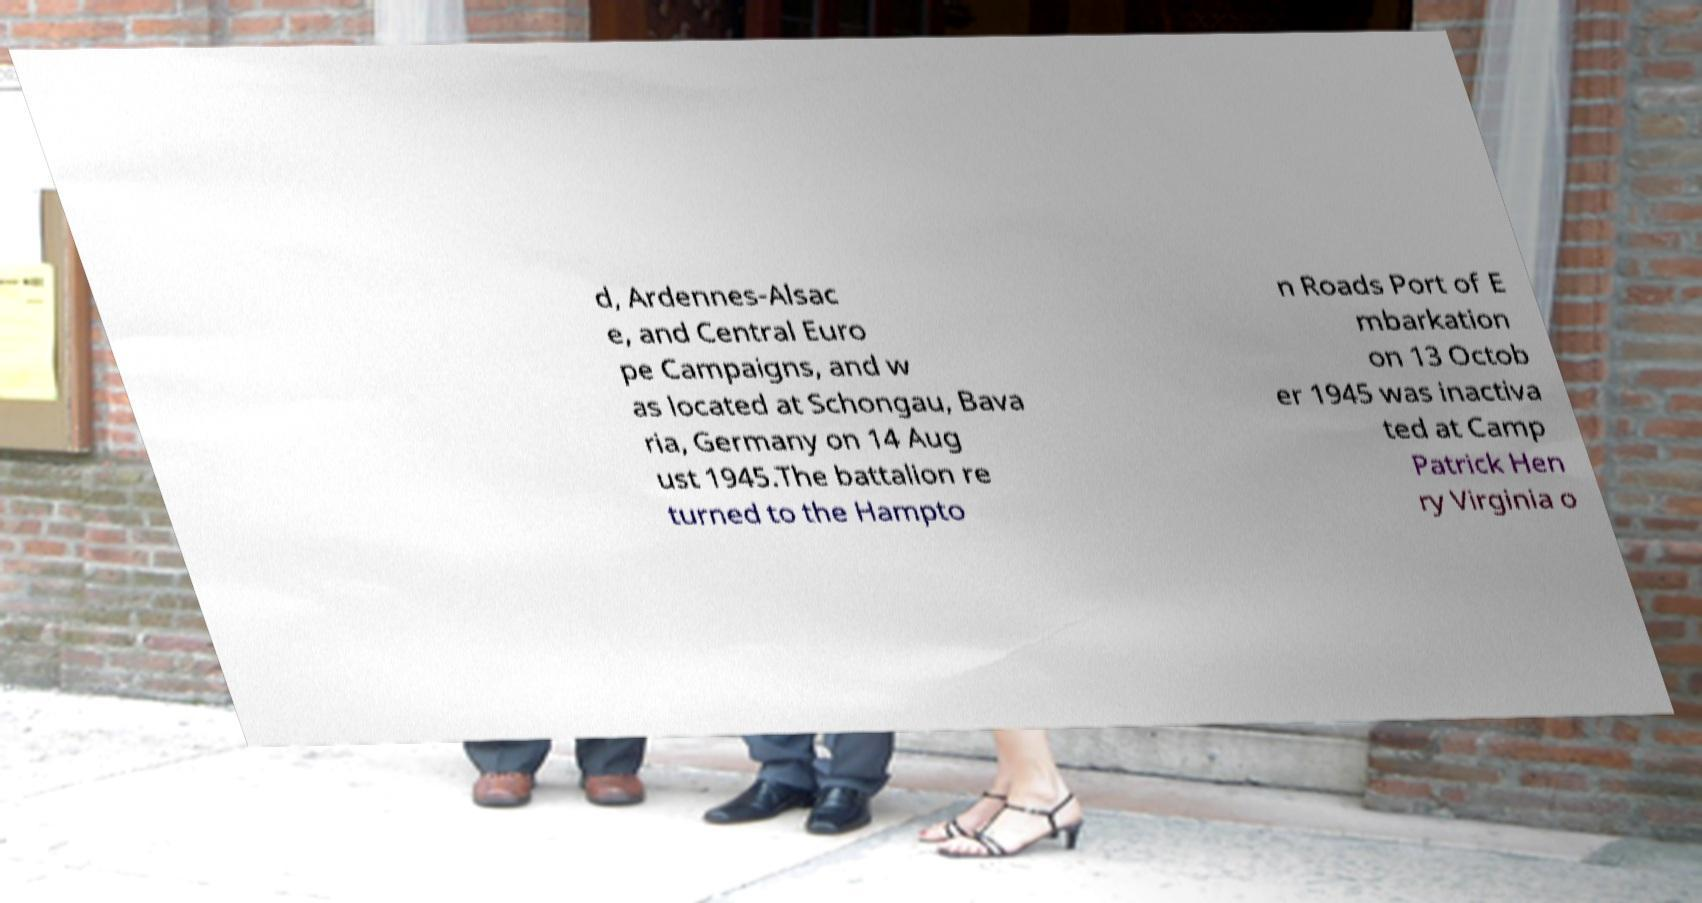Can you accurately transcribe the text from the provided image for me? d, Ardennes-Alsac e, and Central Euro pe Campaigns, and w as located at Schongau, Bava ria, Germany on 14 Aug ust 1945.The battalion re turned to the Hampto n Roads Port of E mbarkation on 13 Octob er 1945 was inactiva ted at Camp Patrick Hen ry Virginia o 